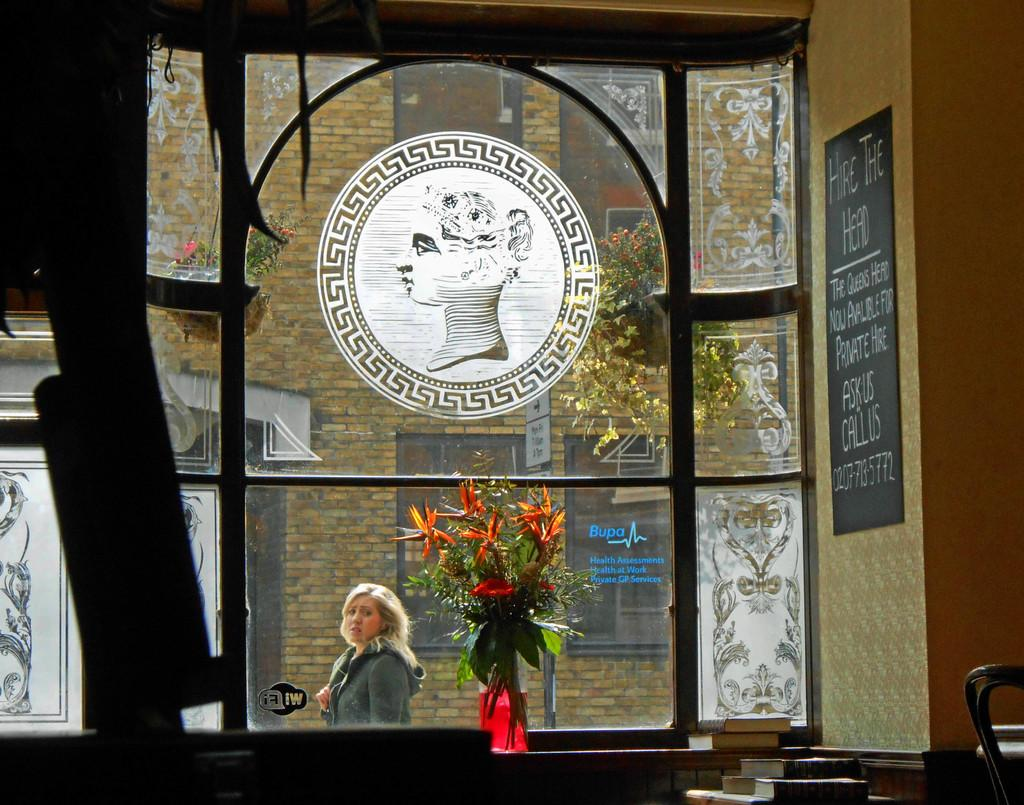<image>
Render a clear and concise summary of the photo. Window view from a room in the Queens Head with a information to private hire  written on a chalkboard 